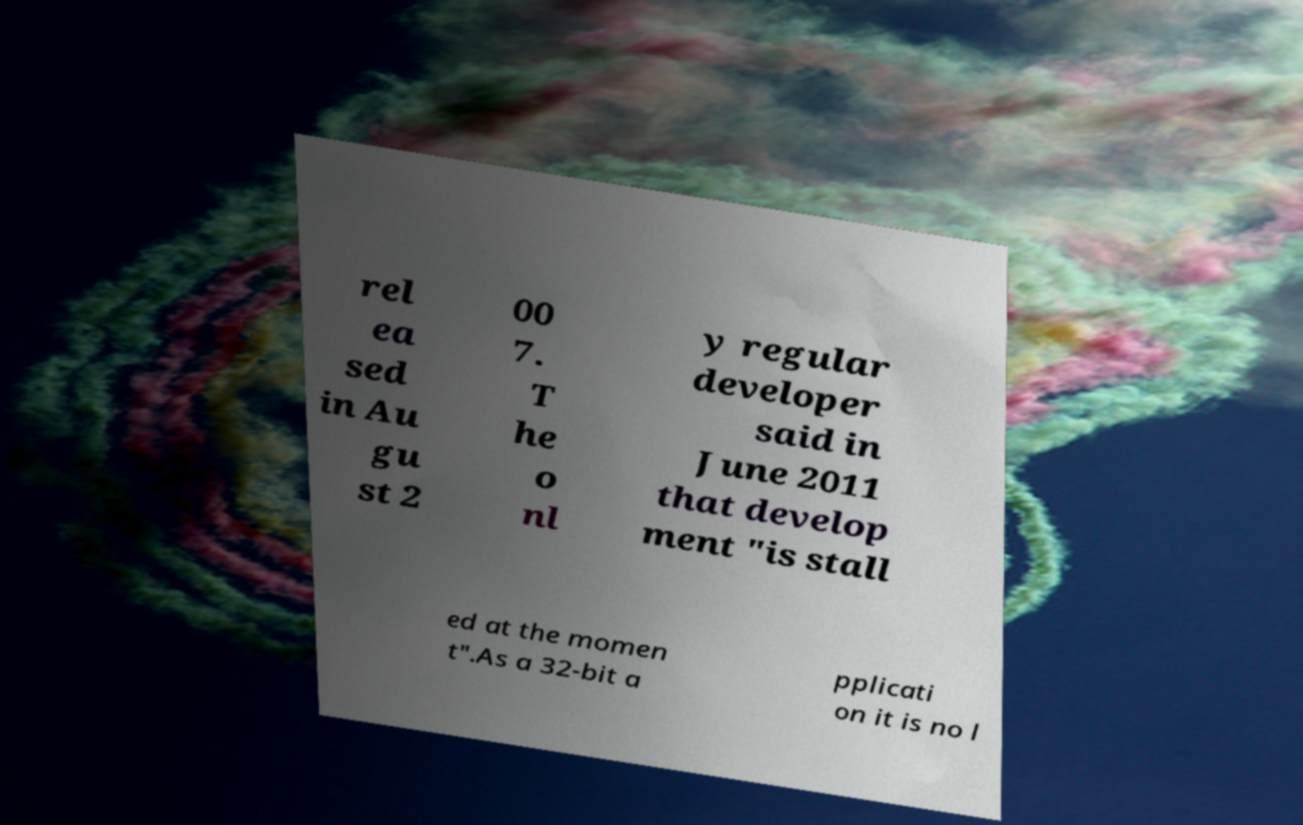There's text embedded in this image that I need extracted. Can you transcribe it verbatim? rel ea sed in Au gu st 2 00 7. T he o nl y regular developer said in June 2011 that develop ment "is stall ed at the momen t".As a 32-bit a pplicati on it is no l 